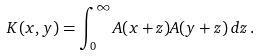<formula> <loc_0><loc_0><loc_500><loc_500>K ( x , y ) = \int _ { 0 } ^ { \infty } A ( x + z ) A ( y + z ) \, d z \, .</formula> 